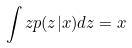Convert formula to latex. <formula><loc_0><loc_0><loc_500><loc_500>\int z p ( z | x ) d z = x</formula> 